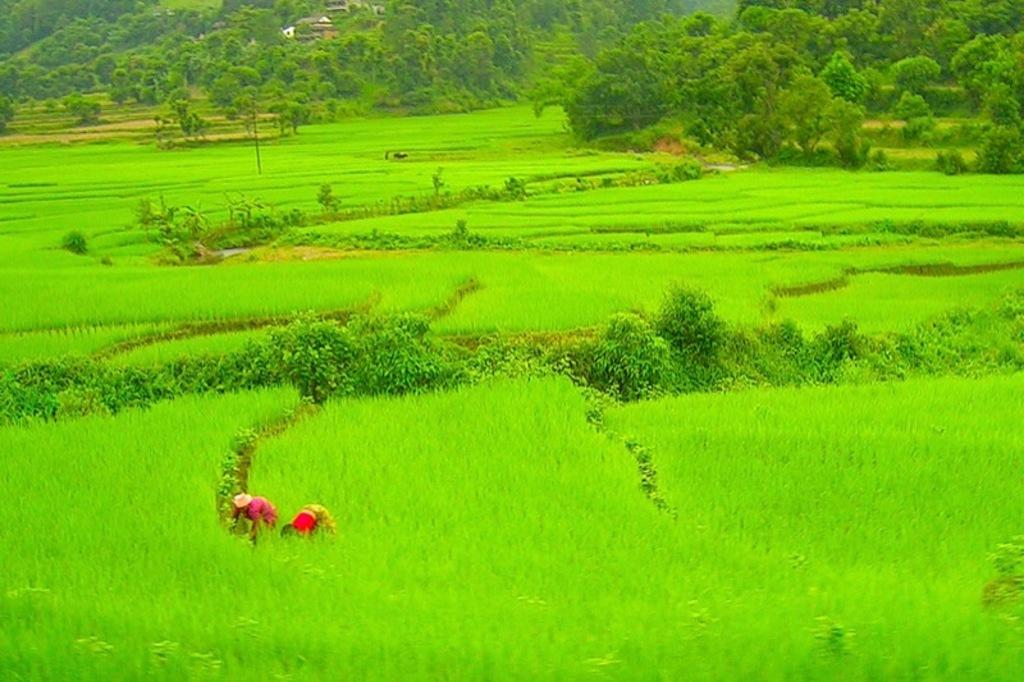What type of terrain is visible in the image? There is an open grass ground in the image. What celestial bodies can be seen in the image? Planets are visible in the image. What type of vegetation is present in the image? There are trees in the image. How many people are in the image? There are two persons in the front of the image. What organization is responsible for washing the planets in the image? There is no organization responsible for washing the planets in the image, as planets do not require washing. 